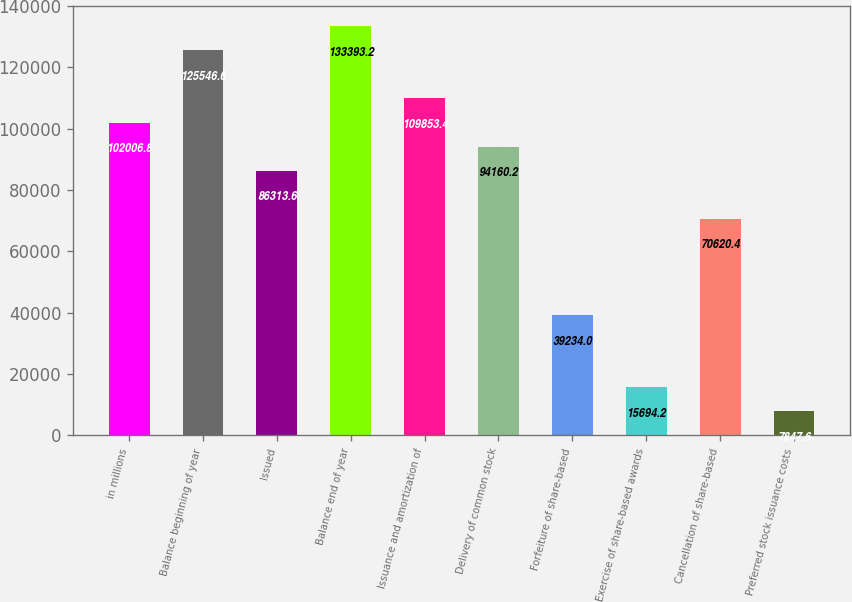<chart> <loc_0><loc_0><loc_500><loc_500><bar_chart><fcel>in millions<fcel>Balance beginning of year<fcel>Issued<fcel>Balance end of year<fcel>Issuance and amortization of<fcel>Delivery of common stock<fcel>Forfeiture of share-based<fcel>Exercise of share-based awards<fcel>Cancellation of share-based<fcel>Preferred stock issuance costs<nl><fcel>102007<fcel>125547<fcel>86313.6<fcel>133393<fcel>109853<fcel>94160.2<fcel>39234<fcel>15694.2<fcel>70620.4<fcel>7847.6<nl></chart> 